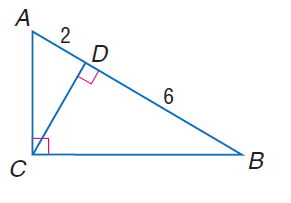Answer the mathemtical geometry problem and directly provide the correct option letter.
Question: Find the measure of the altitude drawn to the hypotenuse.
Choices: A: 2 \sqrt { 3 } B: 2 \sqrt { 6 } C: 2 \sqrt { 6 } D: 4 \sqrt { 3 } A 